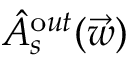<formula> <loc_0><loc_0><loc_500><loc_500>\hat { A } _ { s } ^ { \mathrm o u t } ( \vec { w } )</formula> 